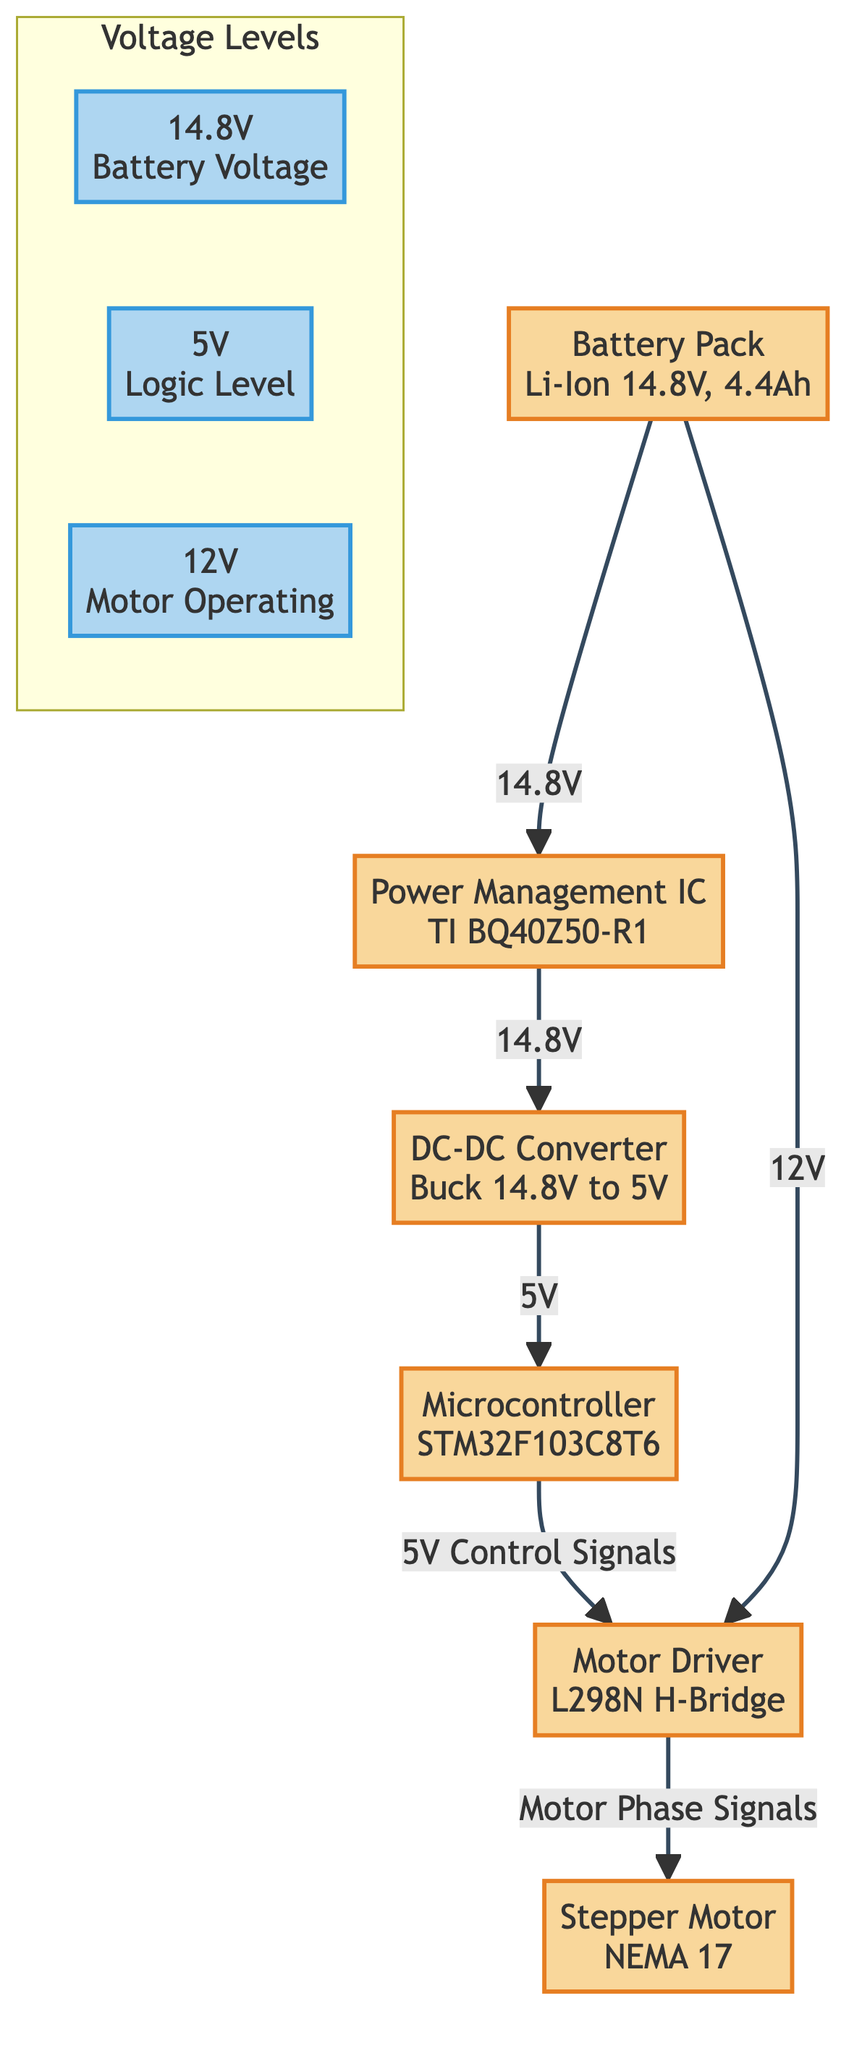What is the voltage supplied by the battery pack? The diagram shows the battery pack labeled with 14.8V, indicating that this is the voltage supplied by the battery.
Answer: 14.8V Which component receives 5V from the DC-DC converter? The diagram indicates that the DC-DC Converter outputs 5V, which is directly connected to the Microcontroller, thus the Microcontroller receives this voltage.
Answer: Microcontroller How many components are there in the diagram? Counting all the labeled components in the diagram, there are a total of six components: Battery Pack, Power Management IC, DC-DC Converter, Microcontroller, Motor Driver, and Stepper Motor.
Answer: 6 What is the operating voltage of the motor driver? The diagram specifies that the Motor Driver is receiving 12V, which is indicated by the label connected to it from the battery pack.
Answer: 12V Which component sends control signals to the motor driver? The diagram illustrates that the Microcontroller outputs control signals to the Motor Driver, which is explicitly shown by the arrow connecting these two components.
Answer: Microcontroller What is the role of the Power Management IC? The Power Management IC is responsible for regulating the voltage levels and it connects the battery pack to the DC-DC Converter, managing the flow of 14.8V voltage.
Answer: Voltage regulation Which component does the motor driver communicate with? From the diagram, it is shown that the Motor Driver communicates with the Stepper Motor, as depicted by the arrows indicating motor phase signals being sent to the motor.
Answer: Stepper Motor What is the connection type between the battery pack and the DC-DC Converter? The diagram indicates a direct connection from the battery pack to the DC-DC Converter, represented by the arrow labeled with 14.8V.
Answer: Direct connection What voltage does the DC-DC converter step down to? According to the diagram, the DC-DC Converter is stepping down the voltage to 5V, as indicated by the arrow from the DC-DC Converter to the Microcontroller.
Answer: 5V How many different voltage levels are indicated in the diagram? The diagram shows three distinct voltage levels: 14.8V from the Battery Pack, 12V for the Motor Operation, and 5V for the Logic Level, totaling three different levels.
Answer: 3 